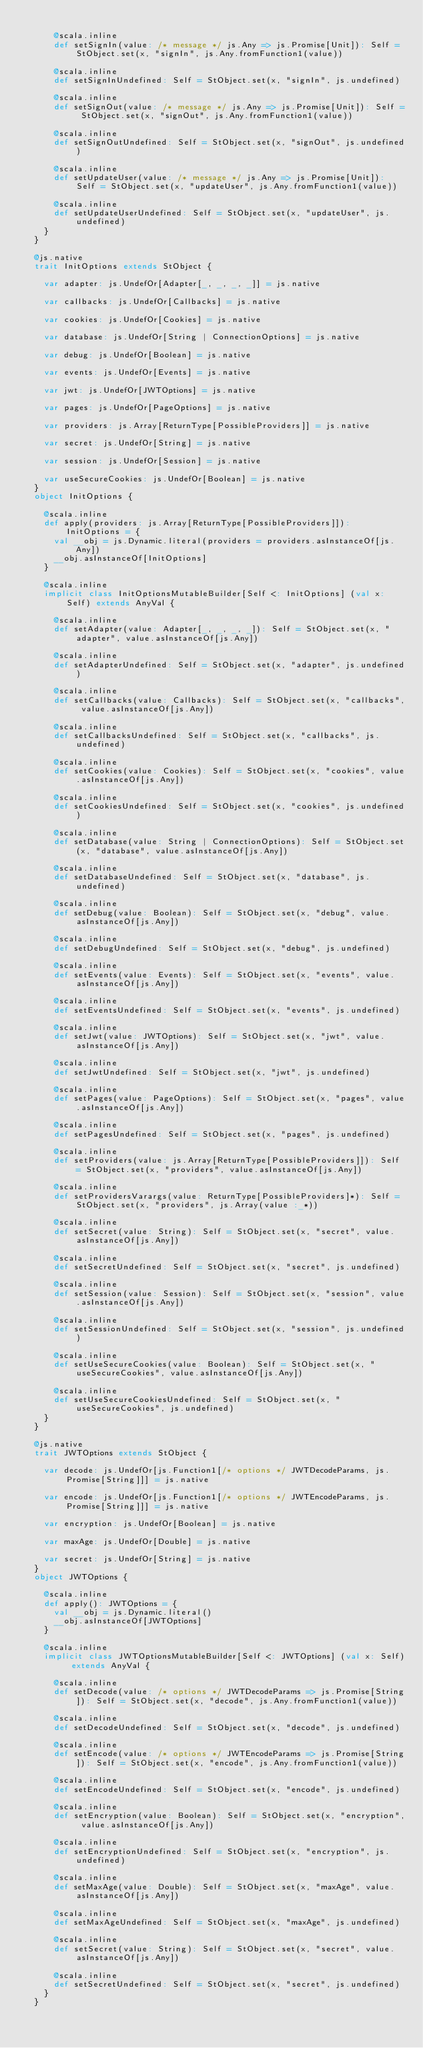Convert code to text. <code><loc_0><loc_0><loc_500><loc_500><_Scala_>      
      @scala.inline
      def setSignIn(value: /* message */ js.Any => js.Promise[Unit]): Self = StObject.set(x, "signIn", js.Any.fromFunction1(value))
      
      @scala.inline
      def setSignInUndefined: Self = StObject.set(x, "signIn", js.undefined)
      
      @scala.inline
      def setSignOut(value: /* message */ js.Any => js.Promise[Unit]): Self = StObject.set(x, "signOut", js.Any.fromFunction1(value))
      
      @scala.inline
      def setSignOutUndefined: Self = StObject.set(x, "signOut", js.undefined)
      
      @scala.inline
      def setUpdateUser(value: /* message */ js.Any => js.Promise[Unit]): Self = StObject.set(x, "updateUser", js.Any.fromFunction1(value))
      
      @scala.inline
      def setUpdateUserUndefined: Self = StObject.set(x, "updateUser", js.undefined)
    }
  }
  
  @js.native
  trait InitOptions extends StObject {
    
    var adapter: js.UndefOr[Adapter[_, _, _, _]] = js.native
    
    var callbacks: js.UndefOr[Callbacks] = js.native
    
    var cookies: js.UndefOr[Cookies] = js.native
    
    var database: js.UndefOr[String | ConnectionOptions] = js.native
    
    var debug: js.UndefOr[Boolean] = js.native
    
    var events: js.UndefOr[Events] = js.native
    
    var jwt: js.UndefOr[JWTOptions] = js.native
    
    var pages: js.UndefOr[PageOptions] = js.native
    
    var providers: js.Array[ReturnType[PossibleProviders]] = js.native
    
    var secret: js.UndefOr[String] = js.native
    
    var session: js.UndefOr[Session] = js.native
    
    var useSecureCookies: js.UndefOr[Boolean] = js.native
  }
  object InitOptions {
    
    @scala.inline
    def apply(providers: js.Array[ReturnType[PossibleProviders]]): InitOptions = {
      val __obj = js.Dynamic.literal(providers = providers.asInstanceOf[js.Any])
      __obj.asInstanceOf[InitOptions]
    }
    
    @scala.inline
    implicit class InitOptionsMutableBuilder[Self <: InitOptions] (val x: Self) extends AnyVal {
      
      @scala.inline
      def setAdapter(value: Adapter[_, _, _, _]): Self = StObject.set(x, "adapter", value.asInstanceOf[js.Any])
      
      @scala.inline
      def setAdapterUndefined: Self = StObject.set(x, "adapter", js.undefined)
      
      @scala.inline
      def setCallbacks(value: Callbacks): Self = StObject.set(x, "callbacks", value.asInstanceOf[js.Any])
      
      @scala.inline
      def setCallbacksUndefined: Self = StObject.set(x, "callbacks", js.undefined)
      
      @scala.inline
      def setCookies(value: Cookies): Self = StObject.set(x, "cookies", value.asInstanceOf[js.Any])
      
      @scala.inline
      def setCookiesUndefined: Self = StObject.set(x, "cookies", js.undefined)
      
      @scala.inline
      def setDatabase(value: String | ConnectionOptions): Self = StObject.set(x, "database", value.asInstanceOf[js.Any])
      
      @scala.inline
      def setDatabaseUndefined: Self = StObject.set(x, "database", js.undefined)
      
      @scala.inline
      def setDebug(value: Boolean): Self = StObject.set(x, "debug", value.asInstanceOf[js.Any])
      
      @scala.inline
      def setDebugUndefined: Self = StObject.set(x, "debug", js.undefined)
      
      @scala.inline
      def setEvents(value: Events): Self = StObject.set(x, "events", value.asInstanceOf[js.Any])
      
      @scala.inline
      def setEventsUndefined: Self = StObject.set(x, "events", js.undefined)
      
      @scala.inline
      def setJwt(value: JWTOptions): Self = StObject.set(x, "jwt", value.asInstanceOf[js.Any])
      
      @scala.inline
      def setJwtUndefined: Self = StObject.set(x, "jwt", js.undefined)
      
      @scala.inline
      def setPages(value: PageOptions): Self = StObject.set(x, "pages", value.asInstanceOf[js.Any])
      
      @scala.inline
      def setPagesUndefined: Self = StObject.set(x, "pages", js.undefined)
      
      @scala.inline
      def setProviders(value: js.Array[ReturnType[PossibleProviders]]): Self = StObject.set(x, "providers", value.asInstanceOf[js.Any])
      
      @scala.inline
      def setProvidersVarargs(value: ReturnType[PossibleProviders]*): Self = StObject.set(x, "providers", js.Array(value :_*))
      
      @scala.inline
      def setSecret(value: String): Self = StObject.set(x, "secret", value.asInstanceOf[js.Any])
      
      @scala.inline
      def setSecretUndefined: Self = StObject.set(x, "secret", js.undefined)
      
      @scala.inline
      def setSession(value: Session): Self = StObject.set(x, "session", value.asInstanceOf[js.Any])
      
      @scala.inline
      def setSessionUndefined: Self = StObject.set(x, "session", js.undefined)
      
      @scala.inline
      def setUseSecureCookies(value: Boolean): Self = StObject.set(x, "useSecureCookies", value.asInstanceOf[js.Any])
      
      @scala.inline
      def setUseSecureCookiesUndefined: Self = StObject.set(x, "useSecureCookies", js.undefined)
    }
  }
  
  @js.native
  trait JWTOptions extends StObject {
    
    var decode: js.UndefOr[js.Function1[/* options */ JWTDecodeParams, js.Promise[String]]] = js.native
    
    var encode: js.UndefOr[js.Function1[/* options */ JWTEncodeParams, js.Promise[String]]] = js.native
    
    var encryption: js.UndefOr[Boolean] = js.native
    
    var maxAge: js.UndefOr[Double] = js.native
    
    var secret: js.UndefOr[String] = js.native
  }
  object JWTOptions {
    
    @scala.inline
    def apply(): JWTOptions = {
      val __obj = js.Dynamic.literal()
      __obj.asInstanceOf[JWTOptions]
    }
    
    @scala.inline
    implicit class JWTOptionsMutableBuilder[Self <: JWTOptions] (val x: Self) extends AnyVal {
      
      @scala.inline
      def setDecode(value: /* options */ JWTDecodeParams => js.Promise[String]): Self = StObject.set(x, "decode", js.Any.fromFunction1(value))
      
      @scala.inline
      def setDecodeUndefined: Self = StObject.set(x, "decode", js.undefined)
      
      @scala.inline
      def setEncode(value: /* options */ JWTEncodeParams => js.Promise[String]): Self = StObject.set(x, "encode", js.Any.fromFunction1(value))
      
      @scala.inline
      def setEncodeUndefined: Self = StObject.set(x, "encode", js.undefined)
      
      @scala.inline
      def setEncryption(value: Boolean): Self = StObject.set(x, "encryption", value.asInstanceOf[js.Any])
      
      @scala.inline
      def setEncryptionUndefined: Self = StObject.set(x, "encryption", js.undefined)
      
      @scala.inline
      def setMaxAge(value: Double): Self = StObject.set(x, "maxAge", value.asInstanceOf[js.Any])
      
      @scala.inline
      def setMaxAgeUndefined: Self = StObject.set(x, "maxAge", js.undefined)
      
      @scala.inline
      def setSecret(value: String): Self = StObject.set(x, "secret", value.asInstanceOf[js.Any])
      
      @scala.inline
      def setSecretUndefined: Self = StObject.set(x, "secret", js.undefined)
    }
  }
  </code> 